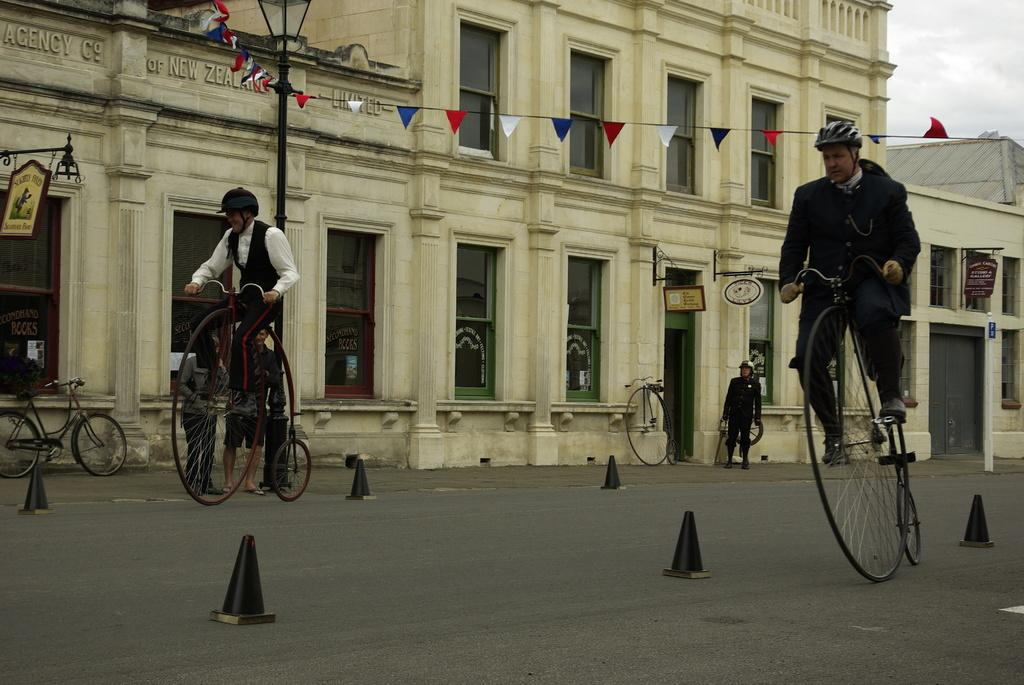How many people are in the image? There are two men in the image. What are the men doing in the image? The men are riding unicycles. What can be seen in the background of the image? There is a building in the background of the image. Is there anyone else in the image besides the two men on unicycles? Yes, there is a man standing in one corner of the image. What color is the statement painted on the building in the image? There is no statement painted on the building in the image, and therefore no color can be determined. 